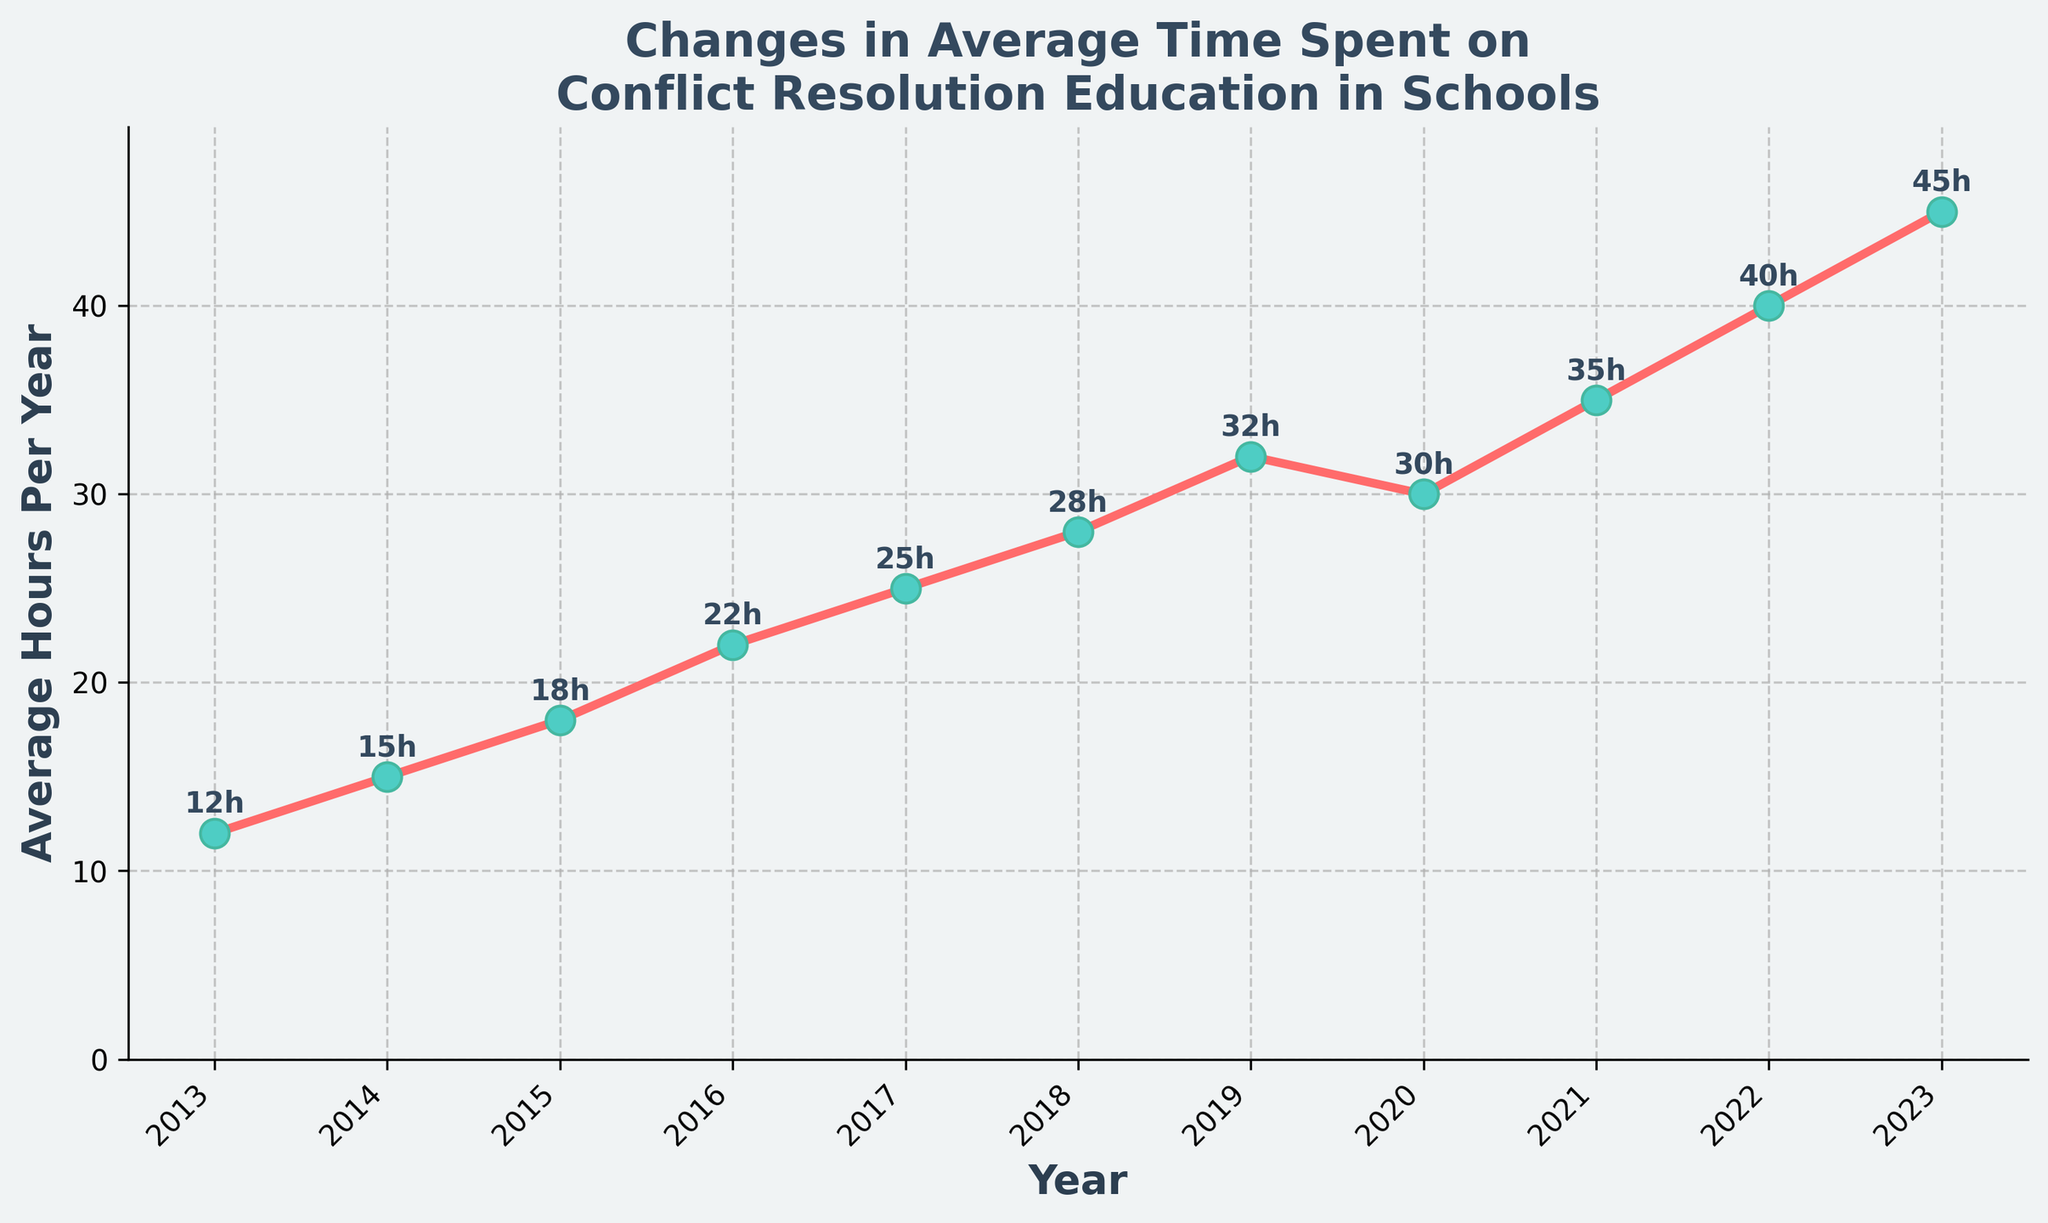What's the average time spent on conflict resolution education in schools over the last decade? Sum the total hours for all the years (12 + 15 + 18 + 22 + 25 + 28 + 32 + 30 + 35 + 40 + 45 = 302), then divide by the number of years (302 / 11). The average is 27.45 hours.
Answer: 27.45 Which year saw a decrease in the average hours compared to the previous year? Look at the plotted line for any year where the next point is lower than the previous one. 2020 has 30 hours compared to 2019's 32 hours, indicating a decrease.
Answer: 2020 How much did the average hours increase from 2013 to 2023? Subtract the average hours in 2013 from the average hours in 2023 (45 - 12). The increase is 33 hours.
Answer: 33 During which year did the largest increase in average hours occur? Determine the difference between each consecutive year and identify the largest one. The largest increase is from 2021 to 2022 (40 - 35 = 5 hours).
Answer: 2022 Is the average time spent on conflict resolution education higher in 2015 or 2021? Compare the plotted points for 2015 and 2021. The average hours in 2015 are 18, while in 2021 it’s 35. Therefore, 2021 is higher.
Answer: 2021 How many years had an average time spent less than 25 hours? Count the number of years where the plotted point is below 25 hours. These years are 2013, 2014, 2015, and 2016.
Answer: 4 What is the median value of average hours spent in the given years? Arrange the values in ascending order (12, 15, 18, 22, 25, 28, 30, 32, 35, 40, 45) and find the middle value, which is 28 (6th value in an 11-element set).
Answer: 28 From which year onwards did the average hours always stay above 20 hours? Identify the first year where the plotted points remain above 20 consistently. This trend starts from 2016 onward.
Answer: 2016 